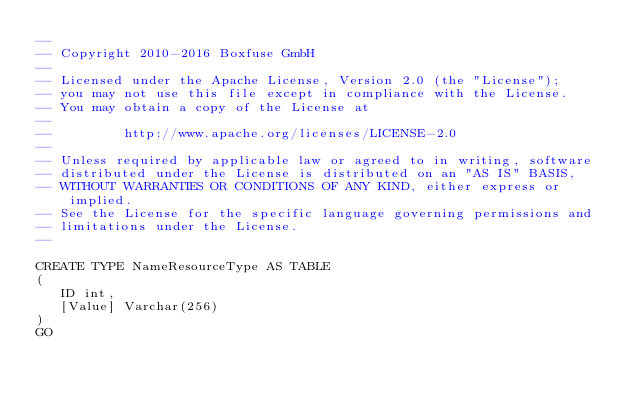<code> <loc_0><loc_0><loc_500><loc_500><_SQL_>--
-- Copyright 2010-2016 Boxfuse GmbH
--
-- Licensed under the Apache License, Version 2.0 (the "License");
-- you may not use this file except in compliance with the License.
-- You may obtain a copy of the License at
--
--         http://www.apache.org/licenses/LICENSE-2.0
--
-- Unless required by applicable law or agreed to in writing, software
-- distributed under the License is distributed on an "AS IS" BASIS,
-- WITHOUT WARRANTIES OR CONDITIONS OF ANY KIND, either express or implied.
-- See the License for the specific language governing permissions and
-- limitations under the License.
--

CREATE TYPE NameResourceType AS TABLE
(
   ID int,
   [Value] Varchar(256)
)
GO
</code> 